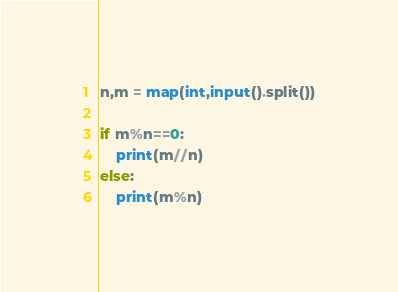<code> <loc_0><loc_0><loc_500><loc_500><_Python_>n,m = map(int,input().split())

if m%n==0:
	print(m//n)
else:
	print(m%n)</code> 